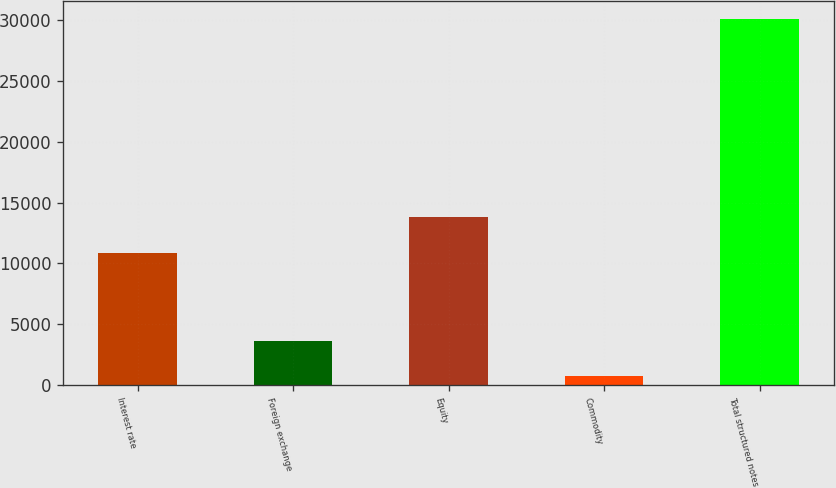Convert chart to OTSL. <chart><loc_0><loc_0><loc_500><loc_500><bar_chart><fcel>Interest rate<fcel>Foreign exchange<fcel>Equity<fcel>Commodity<fcel>Total structured notes<nl><fcel>10858<fcel>3647.9<fcel>13795.9<fcel>710<fcel>30089<nl></chart> 